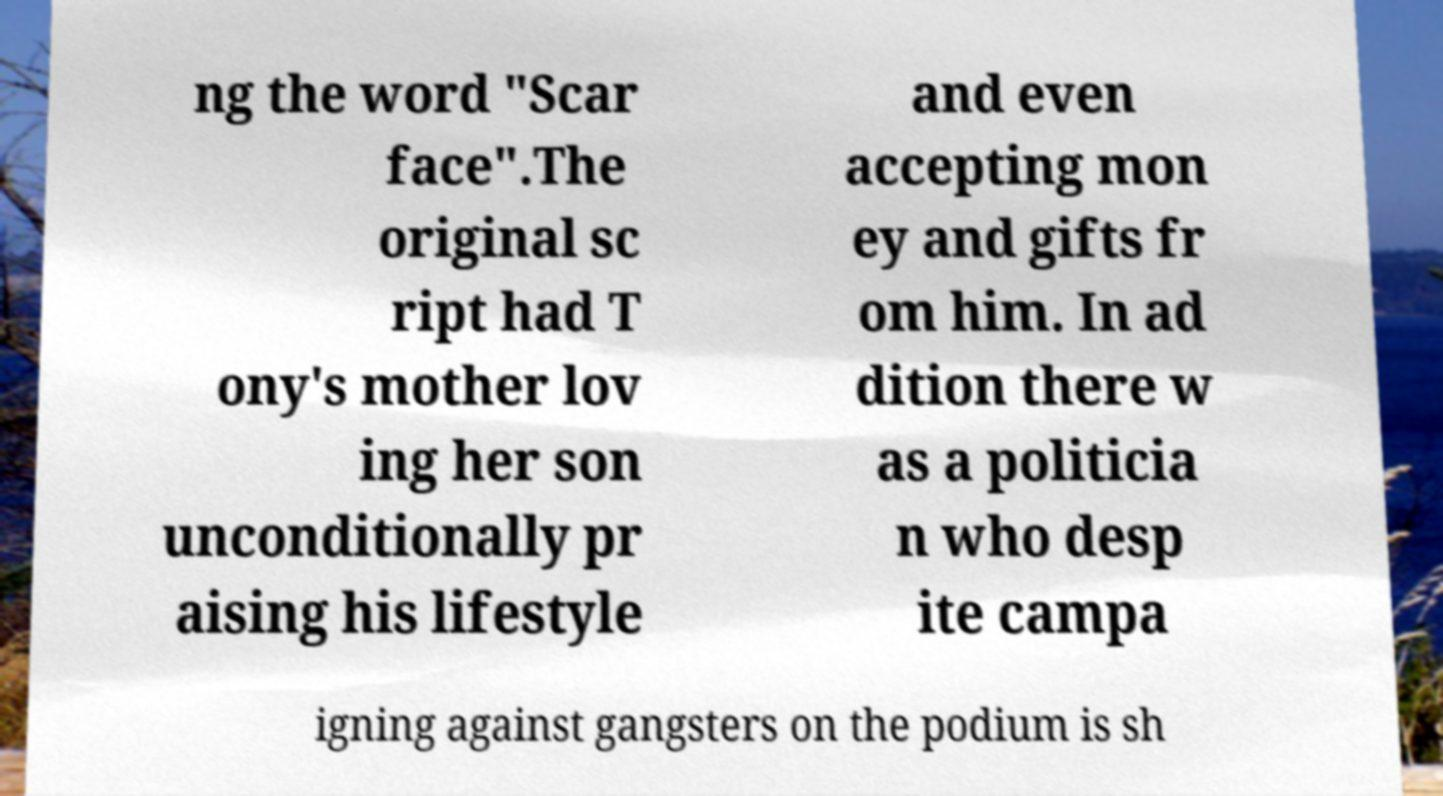I need the written content from this picture converted into text. Can you do that? ng the word "Scar face".The original sc ript had T ony's mother lov ing her son unconditionally pr aising his lifestyle and even accepting mon ey and gifts fr om him. In ad dition there w as a politicia n who desp ite campa igning against gangsters on the podium is sh 